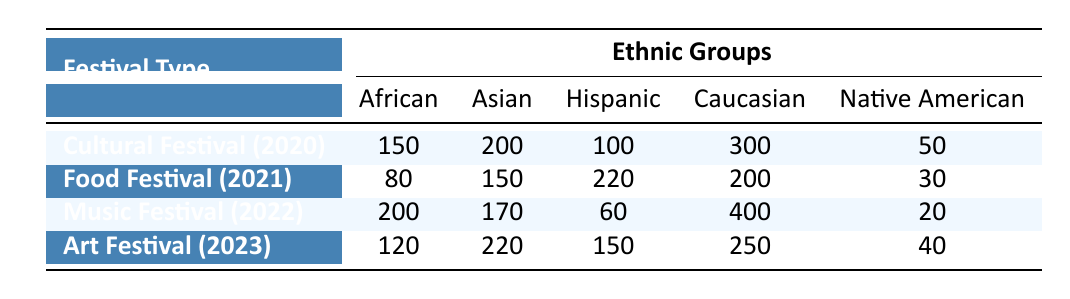What was the highest number of participants in any ethnic group across all festivals? By reviewing the values in each ethnic group column across the different festival types, the highest number is found in the Caucasian group with 400 participants during the Music Festival in 2022.
Answer: 400 How many Hispanic participants attended the Food Festival in 2021? The table directly shows that there were 220 Hispanic participants at the Food Festival in 2021.
Answer: 220 Which festival had the greatest total number of participants from all ethnic groups in the provided data? First, sum the participants for each festival: Cultural Festival (2020) = 150 + 200 + 100 + 300 + 50 = 800, Food Festival (2021) = 80 + 150 + 220 + 200 + 30 = 680, Music Festival (2022) = 200 + 170 + 60 + 400 + 20 = 850, Art Festival (2023) = 120 + 220 + 150 + 250 + 40 = 780. The highest total is from the Music Festival in 2022 with 850 participants.
Answer: 850 Did the number of Asian participants increase from the Cultural Festival in 2020 to the Art Festival in 2023? The number of Asian participants for the Cultural Festival in 2020 is 200, and for the Art Festival in 2023, it is 220. Since 220 is greater than 200, the number did indeed increase.
Answer: Yes What is the average number of African participants across all festivals? Add the African participants: 150 (Cultural) + 80 (Food) + 200 (Music) + 120 (Art) = 550. There are 4 festivals, therefore the average is 550/4 = 137.5.
Answer: 137.5 Were there more Native American participants at the Music Festival in 2022 than at the Food Festival in 2021? The Music Festival in 2022 had 20 Native American participants while the Food Festival in 2021 had 30 Native American participants. Since 20 is less than 30, the statement is false.
Answer: No What percentage of the total participants were Caucasian during the Cultural Festival in 2020? The total number of participants in the Cultural Festival is 800 (from the earlier calculation), where the Caucasian number is 300. The percentage is calculated as (300/800) * 100 = 37.5%.
Answer: 37.5% Which festival had the fewest African participants and how many were there? The Food Festival in 2021 had the fewest African participants with a count of 80, compared to the other festivals.
Answer: 80 What is the total number of Asian participants across the three festivals from 2021 to 2023? The Asian participants for Food Festival (2021) = 150 + Music Festival (2022) = 170 + Art Festival (2023) = 220. The total is 150 + 170 + 220 = 540.
Answer: 540 